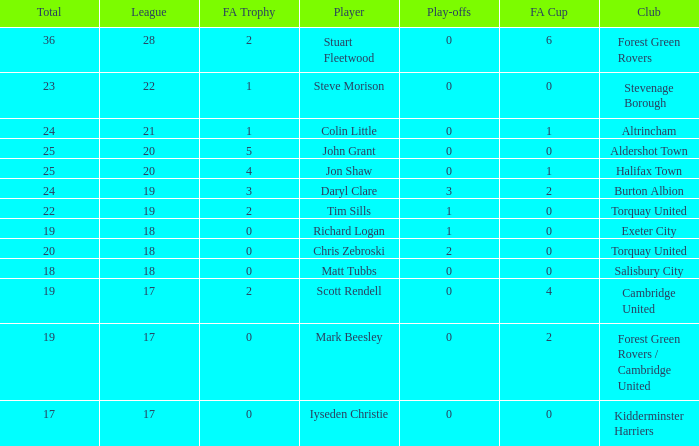What mean total had a league number of 18, Richard Logan as a player, and a play-offs number smaller than 1? None. 